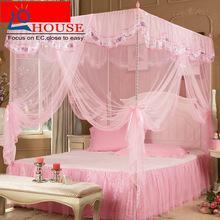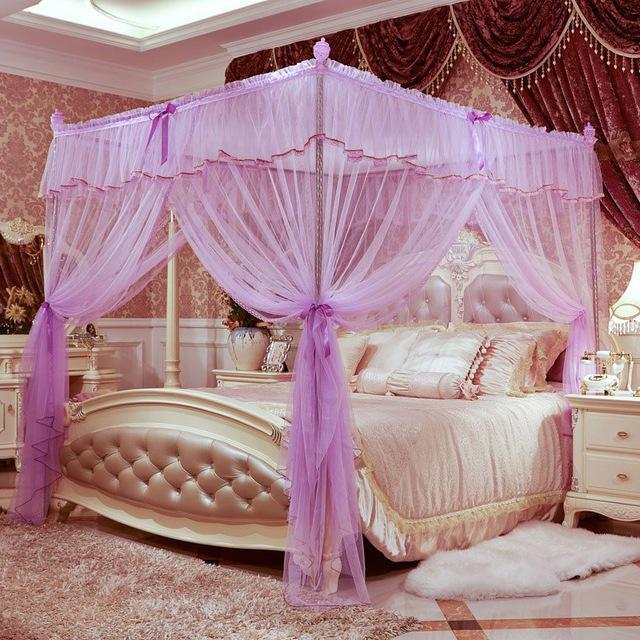The first image is the image on the left, the second image is the image on the right. For the images displayed, is the sentence "The image on the right contains a bed set with a purple net canopy." factually correct? Answer yes or no. Yes. The first image is the image on the left, the second image is the image on the right. Analyze the images presented: Is the assertion "The canopy on the right is a purple or lavender shade, while the canopy on the left is clearly pink." valid? Answer yes or no. Yes. 